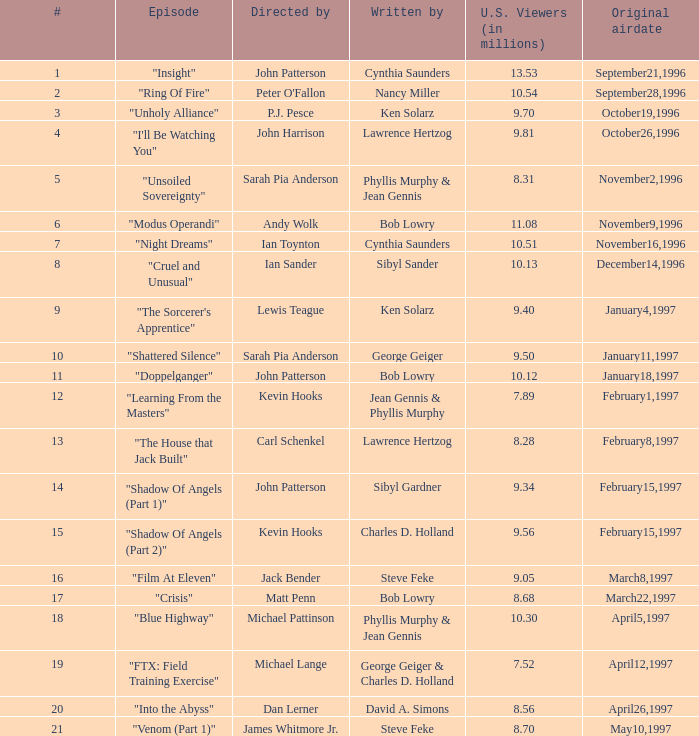81 million us spectators? Lawrence Hertzog. 